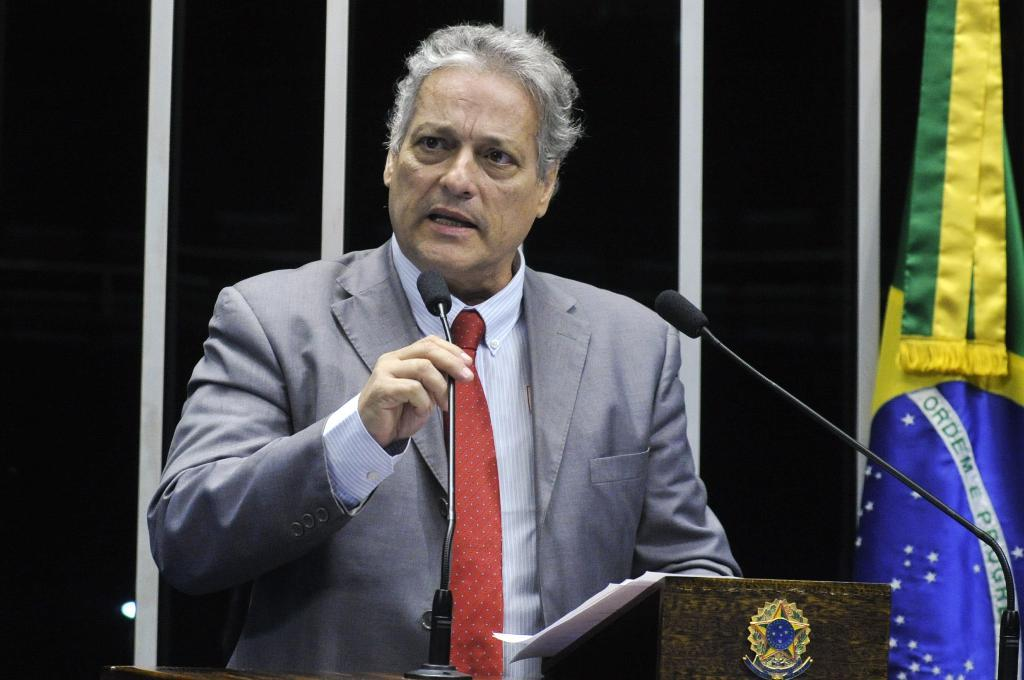What is the man in the image wearing? The man is wearing a grey suit, shirt, and red tie. What is the man doing in the image? The man is talking on a mic. Where is the man standing in the image? The man is standing in front of a dias. What can be seen in front of the wall in the image? There is a flag in front of the wall. What type of bubble can be seen floating near the man in the image? There is no bubble present in the image. Can you tell me how many aunts are standing next to the man in the image? There is no mention of an aunt or any other person standing next to the man in the image. 